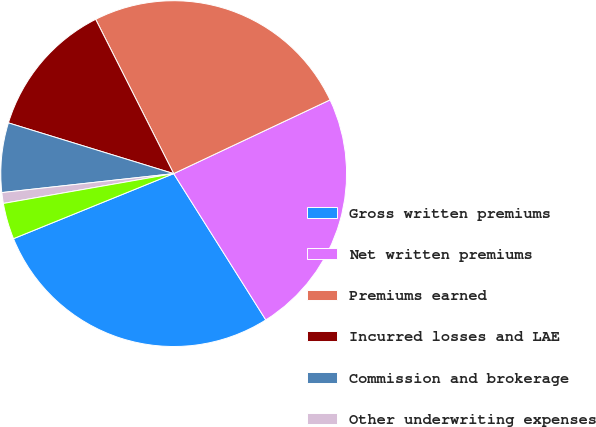Convert chart to OTSL. <chart><loc_0><loc_0><loc_500><loc_500><pie_chart><fcel>Gross written premiums<fcel>Net written premiums<fcel>Premiums earned<fcel>Incurred losses and LAE<fcel>Commission and brokerage<fcel>Other underwriting expenses<fcel>Underwriting gain (loss)<nl><fcel>27.81%<fcel>23.07%<fcel>25.44%<fcel>12.81%<fcel>6.49%<fcel>1.01%<fcel>3.38%<nl></chart> 